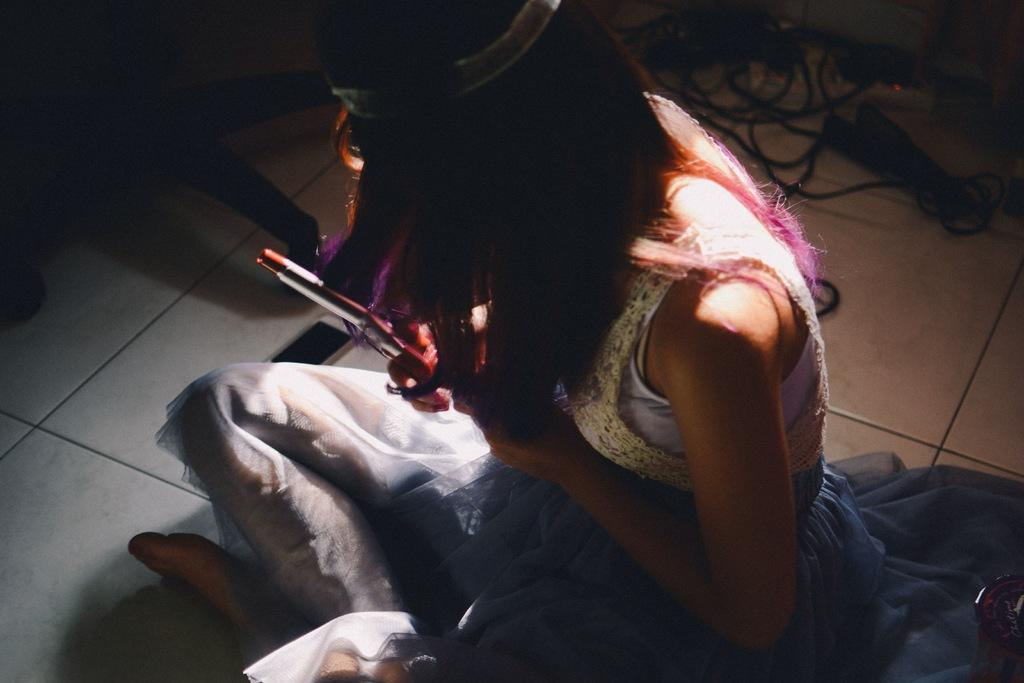Where was the image taken? The image is taken indoors. What can be seen under the girl's feet in the image? There is a floor visible in the image. What is the girl doing in the image? The girl is sitting on the floor in the image. What is the girl holding in her hand? The girl is holding a curl rod in her hand. What type of boot is the girl wearing in the image? The girl is not wearing any boots in the image; she is sitting on the floor with her legs crossed. 